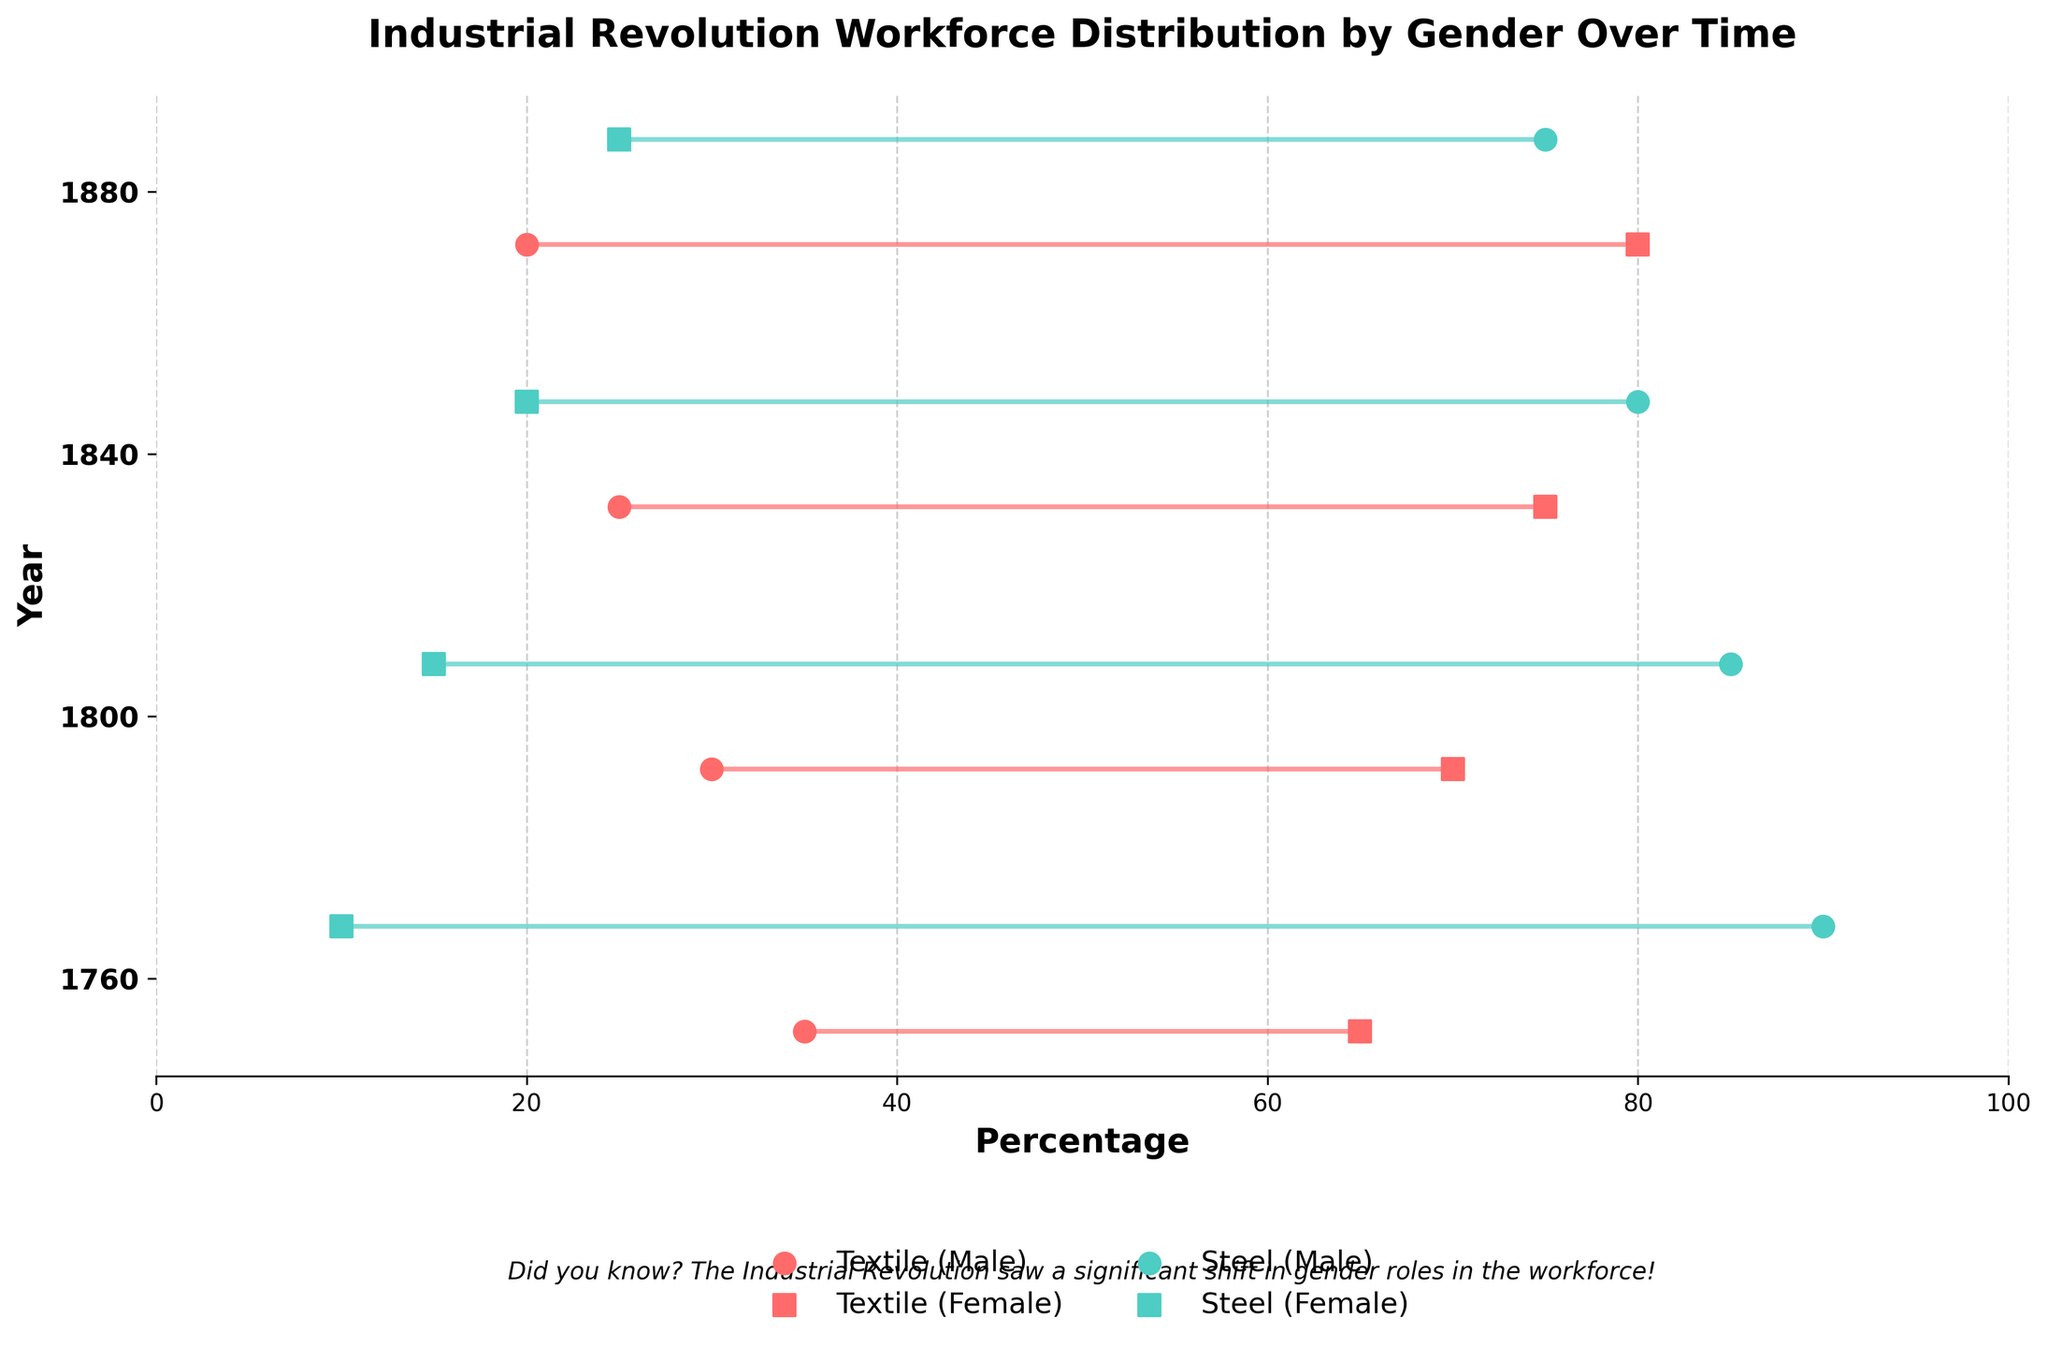What is the title of the plot? The title of the plot is located at the top of the figure. It reads "Industrial Revolution Workforce Distribution by Gender Over Time".
Answer: Industrial Revolution Workforce Distribution by Gender Over Time How does the percentage of females in the Textile industry change from 1760 to 1880? Reading the y-axis labels for years (1760, 1800, 1840, 1880) and following the corresponding data points connected by the lines, the percentages are: 65% in 1760, 70% in 1800, 75% in 1840, and 80% in 1880. We can see an increasing trend.
Answer: It increases Which industry had a higher percentage of males in 1840? Look at the year 1840 and compare the male percentages for both the Textile and Steel industries. The Textile industry has 25% males, while the Steel industry has 80% males.
Answer: Steel In which year was the percentage of females in the Steel industry the highest? Check the female percentages for the Steel industry across the years provided: 10% (1760), 15% (1800), 20% (1840), 25% (1880). The highest percentage is 25% in 1880.
Answer: 1880 By what percentage did the male workforce in the Steel industry decrease from 1760 to 1880? The male workforce percentage in the Steel industry in 1760 was 90% and in 1880 it was 75%. The decrease is calculated as 90% - 75% = 15%.
Answer: 15% How does the gender distribution in the Textile industry compare between 1800 and 1840? In 1800, the Textile industry had 30% males and 70% females. In 1840, it had 25% males and 75% females. By comparing these, we observe a 5% decrease in male representation and a 5% increase in female representation.
Answer: 5% decrease in males, 5% increase in females What is the difference in female workforce percentage between the Textile and Steel industries in 1760? In 1760, the female workforce percentage in the Textile industry is 65% and in the Steel industry is 10%. The difference is calculated as 65% - 10% = 55%.
Answer: 55% Did the male workforce percentage in the Textile industry ever increase from 1760 to 1880? Examining the male workforce percentages for the Textile industry, we have 35% (1760), 30% (1800), 25% (1840), and 20% (1880). The percentage consistently decreases over time with no increase.
Answer: No Which industry shows more pronounced gender disparity in 1800? Check the gender percentages for both industries in 1800. In the Textile industry, 30% males vs. 70% females (a difference of 40%). In the Steel industry, 85% males vs. 15% females (a difference of 70%). The Steel industry shows a greater gender disparity.
Answer: Steel What is the average percentage of females in the Steel industry over the years presented? Sum the female workforce percentages for the Steel industry: 10% (1760), 15% (1800), 20% (1840), and 25% (1880). The sum is 10 + 15 + 20 + 25 = 70. The number of data points is 4. The average is 70 / 4 = 17.5%.
Answer: 17.5% 